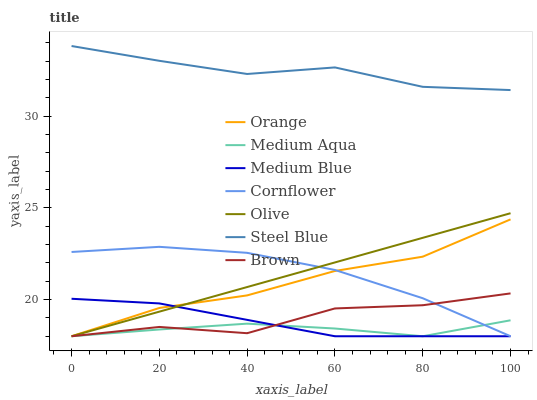Does Medium Aqua have the minimum area under the curve?
Answer yes or no. Yes. Does Steel Blue have the maximum area under the curve?
Answer yes or no. Yes. Does Brown have the minimum area under the curve?
Answer yes or no. No. Does Brown have the maximum area under the curve?
Answer yes or no. No. Is Olive the smoothest?
Answer yes or no. Yes. Is Brown the roughest?
Answer yes or no. Yes. Is Medium Blue the smoothest?
Answer yes or no. No. Is Medium Blue the roughest?
Answer yes or no. No. Does Cornflower have the lowest value?
Answer yes or no. Yes. Does Steel Blue have the lowest value?
Answer yes or no. No. Does Steel Blue have the highest value?
Answer yes or no. Yes. Does Brown have the highest value?
Answer yes or no. No. Is Brown less than Steel Blue?
Answer yes or no. Yes. Is Steel Blue greater than Medium Aqua?
Answer yes or no. Yes. Does Medium Aqua intersect Brown?
Answer yes or no. Yes. Is Medium Aqua less than Brown?
Answer yes or no. No. Is Medium Aqua greater than Brown?
Answer yes or no. No. Does Brown intersect Steel Blue?
Answer yes or no. No. 